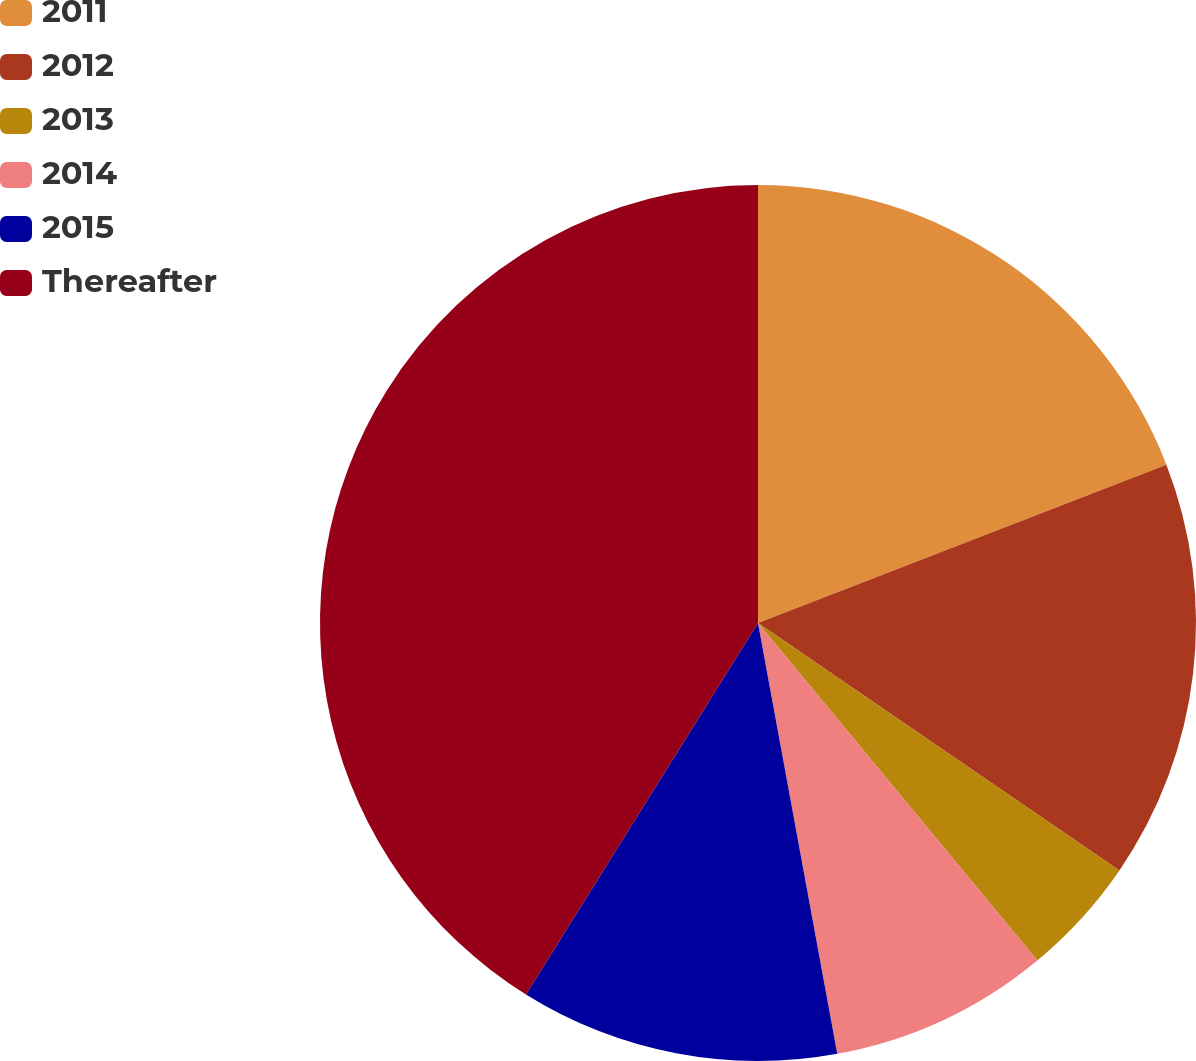<chart> <loc_0><loc_0><loc_500><loc_500><pie_chart><fcel>2011<fcel>2012<fcel>2013<fcel>2014<fcel>2015<fcel>Thereafter<nl><fcel>19.11%<fcel>15.44%<fcel>4.44%<fcel>8.11%<fcel>11.78%<fcel>41.11%<nl></chart> 